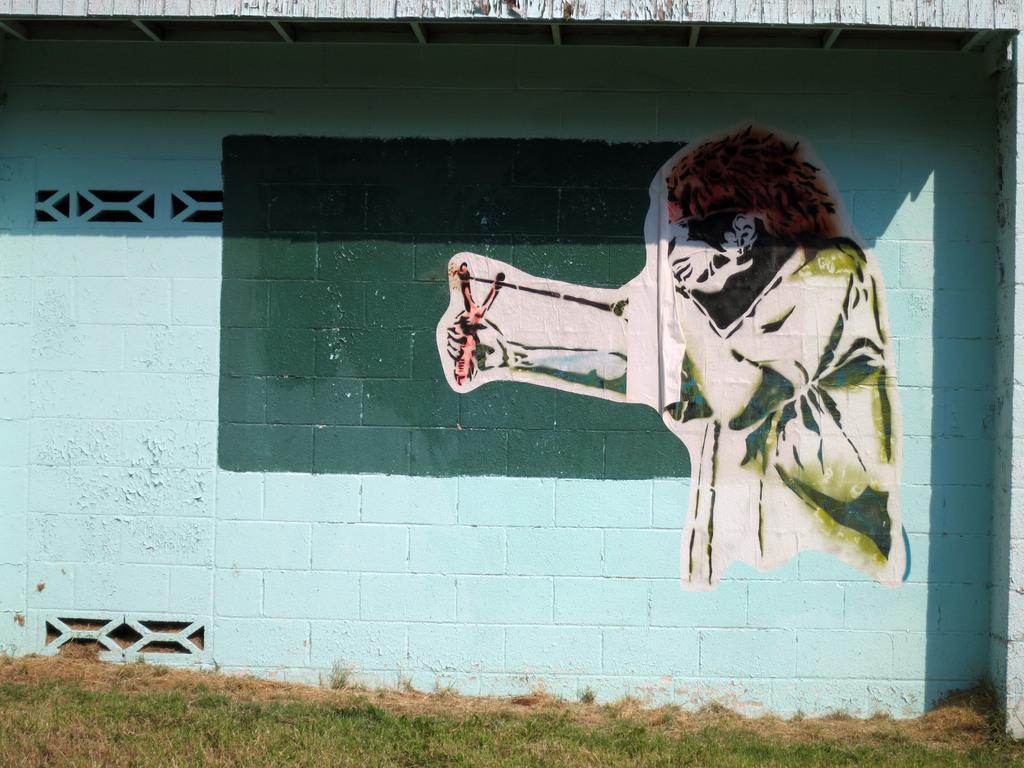Can you describe this image briefly? In the picture we can see painting of a person which is on the wall and we can see grass at the bottom of the picture. 